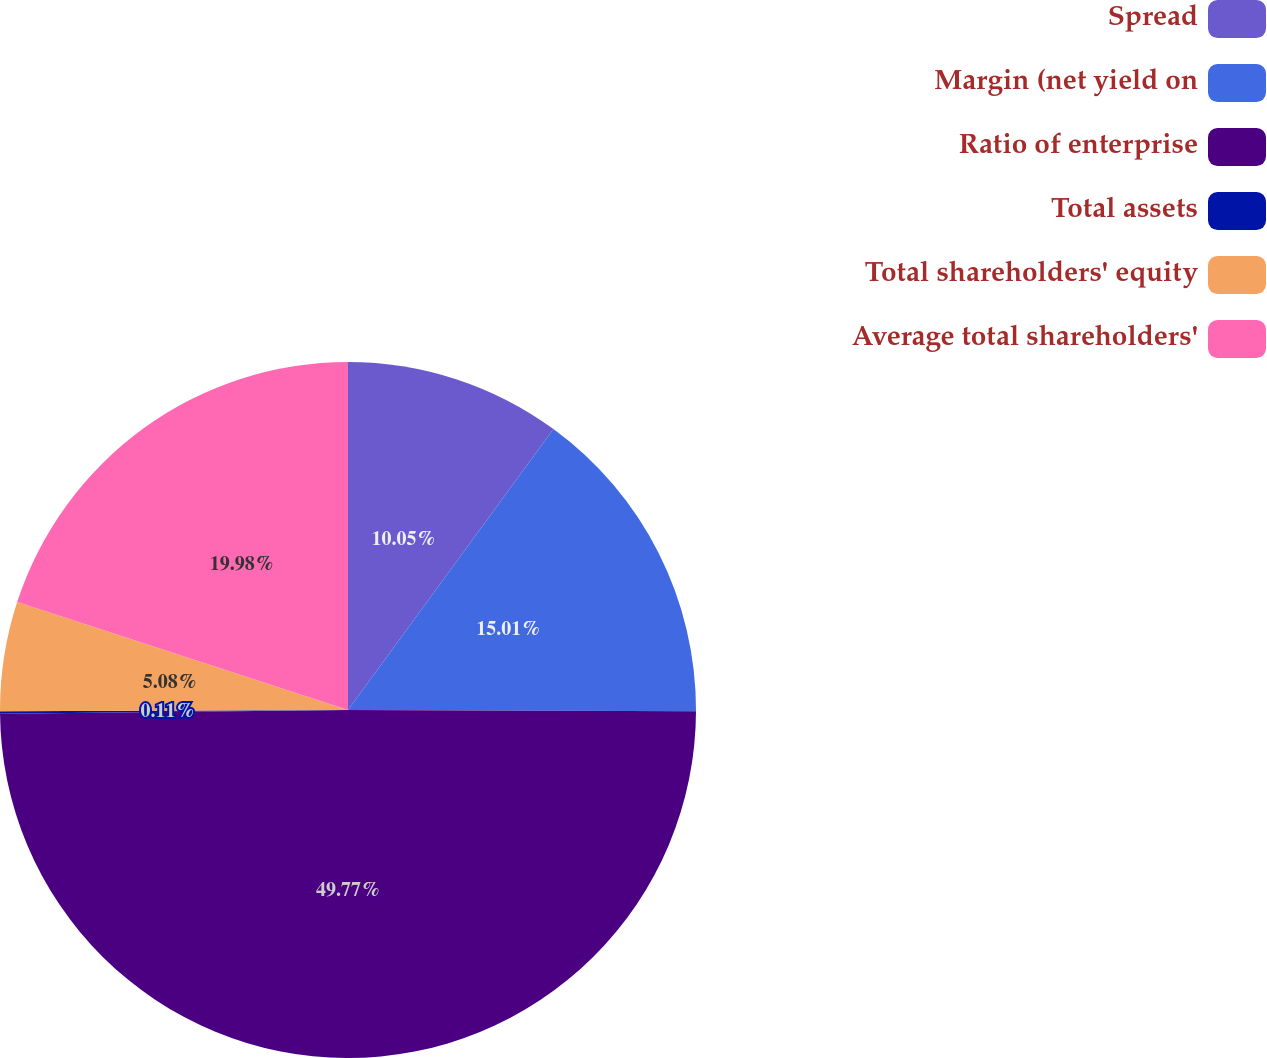Convert chart. <chart><loc_0><loc_0><loc_500><loc_500><pie_chart><fcel>Spread<fcel>Margin (net yield on<fcel>Ratio of enterprise<fcel>Total assets<fcel>Total shareholders' equity<fcel>Average total shareholders'<nl><fcel>10.05%<fcel>15.01%<fcel>49.77%<fcel>0.11%<fcel>5.08%<fcel>19.98%<nl></chart> 